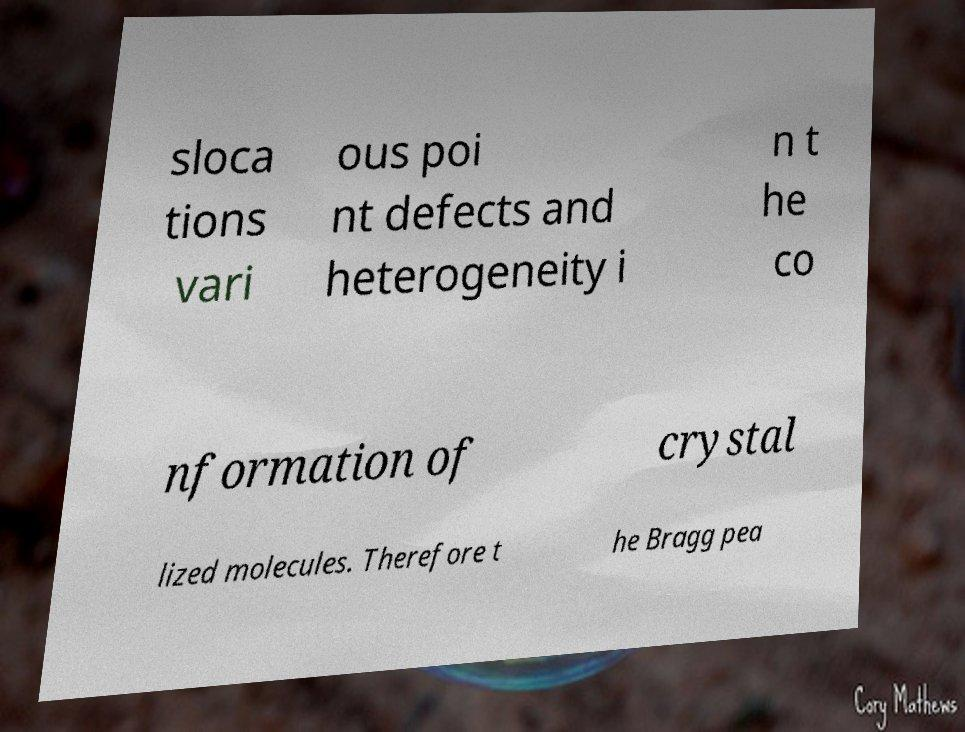Please read and relay the text visible in this image. What does it say? sloca tions vari ous poi nt defects and heterogeneity i n t he co nformation of crystal lized molecules. Therefore t he Bragg pea 